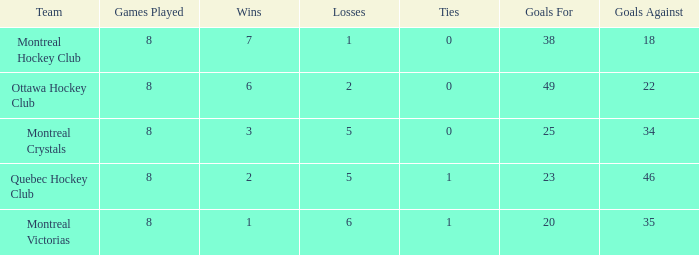With 3 winning outcomes, what is the mean loss count? 5.0. 